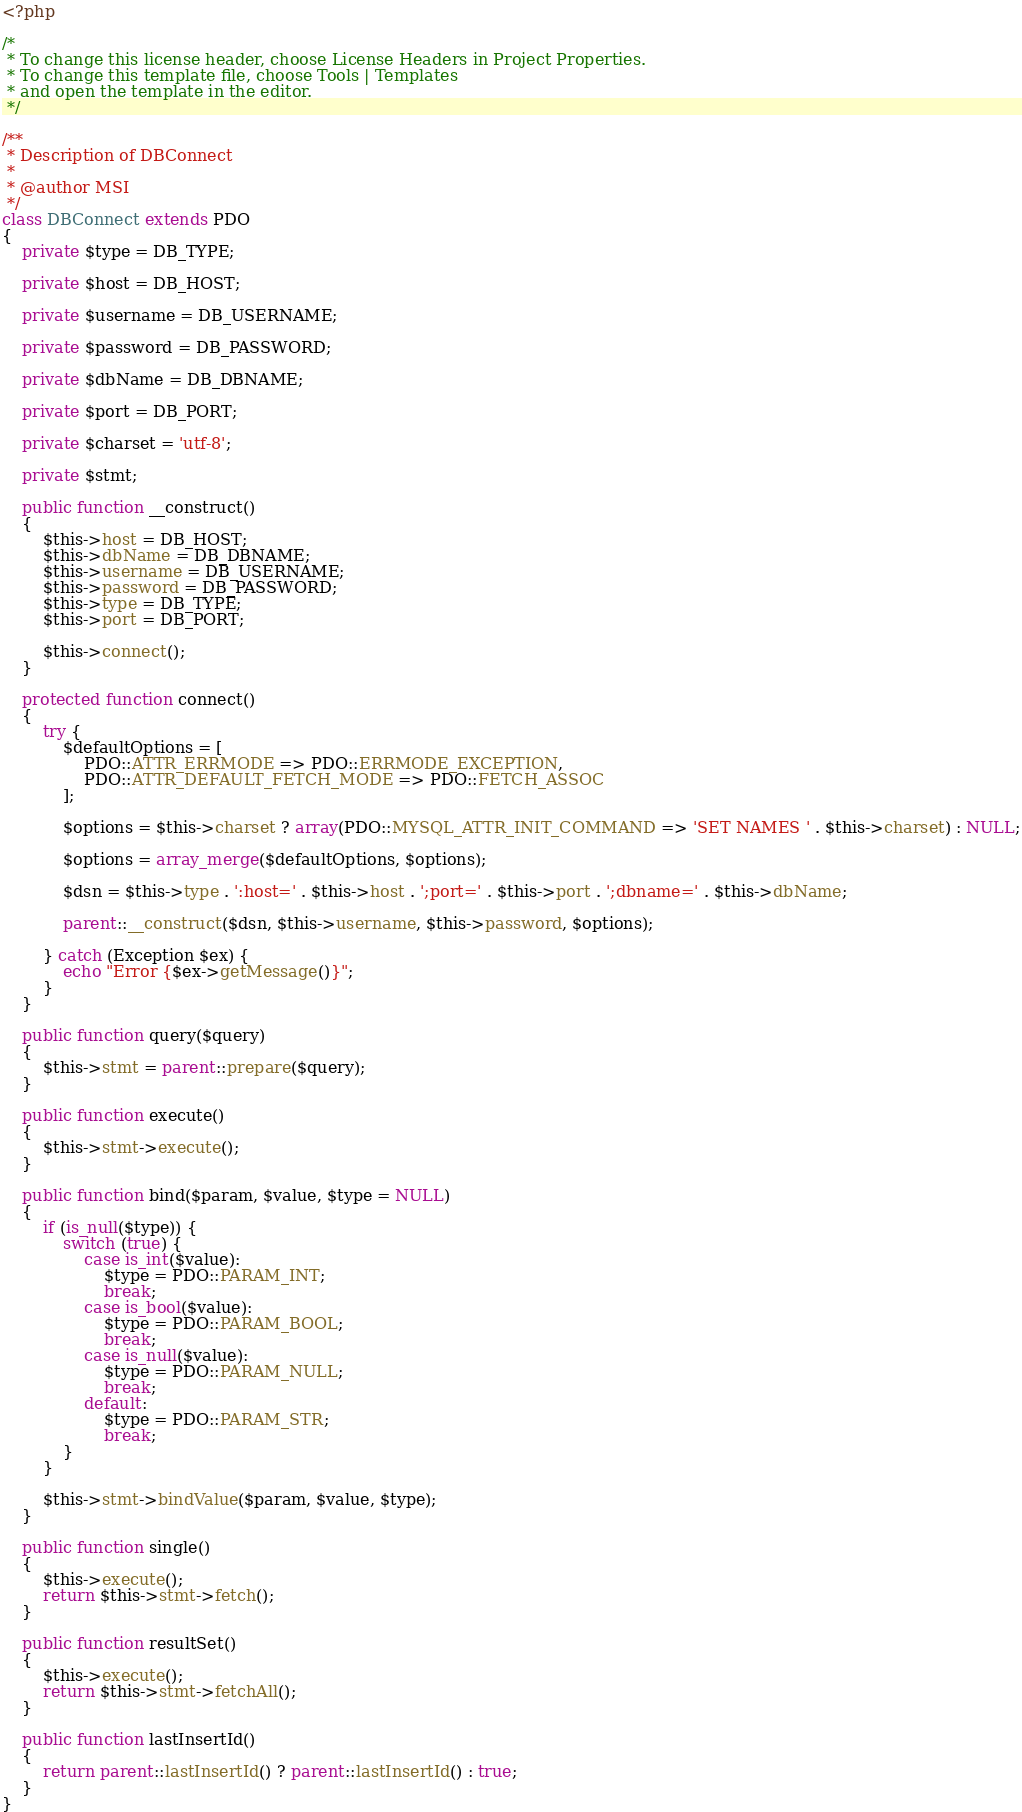<code> <loc_0><loc_0><loc_500><loc_500><_PHP_><?php

/*
 * To change this license header, choose License Headers in Project Properties.
 * To change this template file, choose Tools | Templates
 * and open the template in the editor.
 */

/**
 * Description of DBConnect
 *
 * @author MSI
 */
class DBConnect extends PDO
{
    private $type = DB_TYPE;
    
    private $host = DB_HOST;
    
    private $username = DB_USERNAME;
    
    private $password = DB_PASSWORD;
    
    private $dbName = DB_DBNAME;
    
    private $port = DB_PORT;
    
    private $charset = 'utf-8';
    
    private $stmt;
    
    public function __construct() 
    {
        $this->host = DB_HOST;
        $this->dbName = DB_DBNAME;
        $this->username = DB_USERNAME;
        $this->password = DB_PASSWORD;
        $this->type = DB_TYPE;
        $this->port = DB_PORT;
        
        $this->connect();
    }
    
    protected function connect()
    {
        try {
            $defaultOptions = [
                PDO::ATTR_ERRMODE => PDO::ERRMODE_EXCEPTION,
                PDO::ATTR_DEFAULT_FETCH_MODE => PDO::FETCH_ASSOC
            ];
            
            $options = $this->charset ? array(PDO::MYSQL_ATTR_INIT_COMMAND => 'SET NAMES ' . $this->charset) : NULL;
            
            $options = array_merge($defaultOptions, $options);
            
            $dsn = $this->type . ':host=' . $this->host . ';port=' . $this->port . ';dbname=' . $this->dbName;
            
            parent::__construct($dsn, $this->username, $this->password, $options);
            
        } catch (Exception $ex) {
            echo "Error {$ex->getMessage()}";
        }
    }
    
    public function query($query)
    {
        $this->stmt = parent::prepare($query);
    }
    
    public function execute()
    {
        $this->stmt->execute();
    }
    
    public function bind($param, $value, $type = NULL)
    {
        if (is_null($type)) {
            switch (true) {
                case is_int($value):
                    $type = PDO::PARAM_INT;
                    break;
                case is_bool($value):
                    $type = PDO::PARAM_BOOL;
                    break;
                case is_null($value):
                    $type = PDO::PARAM_NULL;
                    break;
                default:
                    $type = PDO::PARAM_STR;
                    break;
            }
        }
        
        $this->stmt->bindValue($param, $value, $type);
    }
    
    public function single()
    {
        $this->execute();
        return $this->stmt->fetch();
    }
    
    public function resultSet()
    {
        $this->execute();
        return $this->stmt->fetchAll();
    }
    
    public function lastInsertId()
    {
        return parent::lastInsertId() ? parent::lastInsertId() : true;
    }
}
</code> 